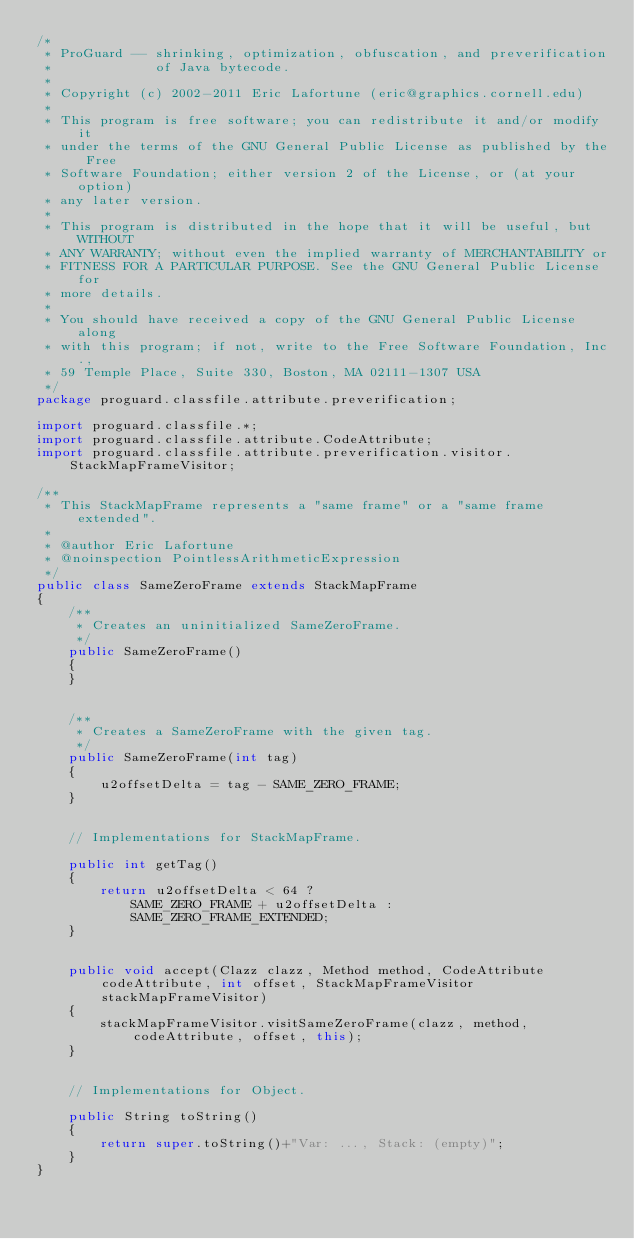<code> <loc_0><loc_0><loc_500><loc_500><_Java_>/*
 * ProGuard -- shrinking, optimization, obfuscation, and preverification
 *             of Java bytecode.
 *
 * Copyright (c) 2002-2011 Eric Lafortune (eric@graphics.cornell.edu)
 *
 * This program is free software; you can redistribute it and/or modify it
 * under the terms of the GNU General Public License as published by the Free
 * Software Foundation; either version 2 of the License, or (at your option)
 * any later version.
 *
 * This program is distributed in the hope that it will be useful, but WITHOUT
 * ANY WARRANTY; without even the implied warranty of MERCHANTABILITY or
 * FITNESS FOR A PARTICULAR PURPOSE. See the GNU General Public License for
 * more details.
 *
 * You should have received a copy of the GNU General Public License along
 * with this program; if not, write to the Free Software Foundation, Inc.,
 * 59 Temple Place, Suite 330, Boston, MA 02111-1307 USA
 */
package proguard.classfile.attribute.preverification;

import proguard.classfile.*;
import proguard.classfile.attribute.CodeAttribute;
import proguard.classfile.attribute.preverification.visitor.StackMapFrameVisitor;

/**
 * This StackMapFrame represents a "same frame" or a "same frame extended".
 *
 * @author Eric Lafortune
 * @noinspection PointlessArithmeticExpression
 */
public class SameZeroFrame extends StackMapFrame
{
    /**
     * Creates an uninitialized SameZeroFrame.
     */
    public SameZeroFrame()
    {
    }


    /**
     * Creates a SameZeroFrame with the given tag.
     */
    public SameZeroFrame(int tag)
    {
        u2offsetDelta = tag - SAME_ZERO_FRAME;
    }


    // Implementations for StackMapFrame.

    public int getTag()
    {
        return u2offsetDelta < 64 ?
            SAME_ZERO_FRAME + u2offsetDelta :
            SAME_ZERO_FRAME_EXTENDED;
    }


    public void accept(Clazz clazz, Method method, CodeAttribute codeAttribute, int offset, StackMapFrameVisitor stackMapFrameVisitor)
    {
        stackMapFrameVisitor.visitSameZeroFrame(clazz, method, codeAttribute, offset, this);
    }


    // Implementations for Object.

    public String toString()
    {
        return super.toString()+"Var: ..., Stack: (empty)";
    }
}
</code> 